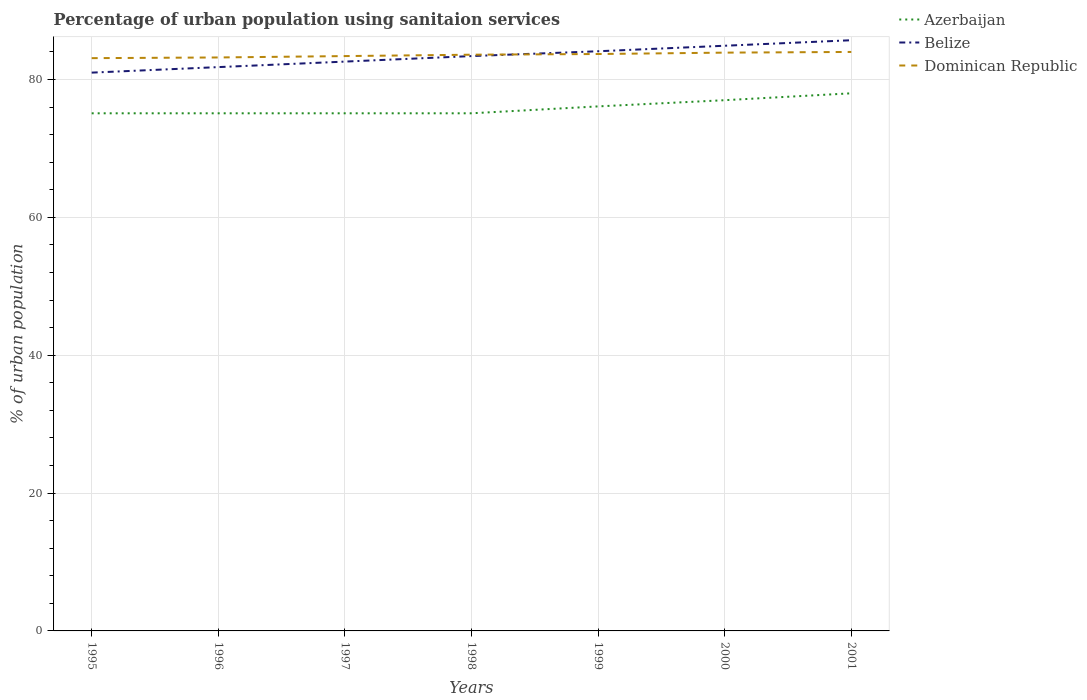Does the line corresponding to Belize intersect with the line corresponding to Dominican Republic?
Ensure brevity in your answer.  Yes. Is the number of lines equal to the number of legend labels?
Your answer should be compact. Yes. Across all years, what is the maximum percentage of urban population using sanitaion services in Dominican Republic?
Provide a short and direct response. 83.1. What is the total percentage of urban population using sanitaion services in Belize in the graph?
Provide a succinct answer. -0.8. What is the difference between the highest and the second highest percentage of urban population using sanitaion services in Belize?
Offer a terse response. 4.7. What is the difference between the highest and the lowest percentage of urban population using sanitaion services in Belize?
Provide a succinct answer. 4. How many years are there in the graph?
Make the answer very short. 7. Are the values on the major ticks of Y-axis written in scientific E-notation?
Your answer should be very brief. No. Does the graph contain any zero values?
Make the answer very short. No. How are the legend labels stacked?
Make the answer very short. Vertical. What is the title of the graph?
Your answer should be compact. Percentage of urban population using sanitaion services. Does "Benin" appear as one of the legend labels in the graph?
Your response must be concise. No. What is the label or title of the X-axis?
Offer a very short reply. Years. What is the label or title of the Y-axis?
Give a very brief answer. % of urban population. What is the % of urban population of Azerbaijan in 1995?
Your answer should be very brief. 75.1. What is the % of urban population in Dominican Republic in 1995?
Provide a succinct answer. 83.1. What is the % of urban population in Azerbaijan in 1996?
Your answer should be very brief. 75.1. What is the % of urban population of Belize in 1996?
Give a very brief answer. 81.8. What is the % of urban population of Dominican Republic in 1996?
Your answer should be very brief. 83.2. What is the % of urban population of Azerbaijan in 1997?
Make the answer very short. 75.1. What is the % of urban population of Belize in 1997?
Your answer should be compact. 82.6. What is the % of urban population of Dominican Republic in 1997?
Offer a terse response. 83.4. What is the % of urban population of Azerbaijan in 1998?
Make the answer very short. 75.1. What is the % of urban population of Belize in 1998?
Keep it short and to the point. 83.4. What is the % of urban population of Dominican Republic in 1998?
Your answer should be compact. 83.6. What is the % of urban population of Azerbaijan in 1999?
Offer a terse response. 76.1. What is the % of urban population of Belize in 1999?
Provide a succinct answer. 84.1. What is the % of urban population of Dominican Republic in 1999?
Provide a short and direct response. 83.7. What is the % of urban population of Belize in 2000?
Ensure brevity in your answer.  84.9. What is the % of urban population of Dominican Republic in 2000?
Your answer should be compact. 83.9. What is the % of urban population in Azerbaijan in 2001?
Your response must be concise. 78. What is the % of urban population in Belize in 2001?
Ensure brevity in your answer.  85.7. Across all years, what is the maximum % of urban population of Belize?
Your response must be concise. 85.7. Across all years, what is the maximum % of urban population of Dominican Republic?
Make the answer very short. 84. Across all years, what is the minimum % of urban population of Azerbaijan?
Give a very brief answer. 75.1. Across all years, what is the minimum % of urban population in Belize?
Keep it short and to the point. 81. Across all years, what is the minimum % of urban population in Dominican Republic?
Offer a very short reply. 83.1. What is the total % of urban population of Azerbaijan in the graph?
Provide a succinct answer. 531.5. What is the total % of urban population in Belize in the graph?
Ensure brevity in your answer.  583.5. What is the total % of urban population in Dominican Republic in the graph?
Your answer should be very brief. 584.9. What is the difference between the % of urban population in Belize in 1995 and that in 1996?
Your response must be concise. -0.8. What is the difference between the % of urban population of Belize in 1995 and that in 1997?
Offer a terse response. -1.6. What is the difference between the % of urban population of Dominican Republic in 1995 and that in 1997?
Keep it short and to the point. -0.3. What is the difference between the % of urban population in Azerbaijan in 1995 and that in 1998?
Offer a very short reply. 0. What is the difference between the % of urban population in Dominican Republic in 1995 and that in 1998?
Provide a short and direct response. -0.5. What is the difference between the % of urban population of Azerbaijan in 1995 and that in 1999?
Your response must be concise. -1. What is the difference between the % of urban population of Azerbaijan in 1995 and that in 2000?
Your answer should be compact. -1.9. What is the difference between the % of urban population in Dominican Republic in 1995 and that in 2000?
Your answer should be very brief. -0.8. What is the difference between the % of urban population in Dominican Republic in 1995 and that in 2001?
Keep it short and to the point. -0.9. What is the difference between the % of urban population of Belize in 1996 and that in 1997?
Offer a very short reply. -0.8. What is the difference between the % of urban population in Dominican Republic in 1996 and that in 1997?
Offer a very short reply. -0.2. What is the difference between the % of urban population of Azerbaijan in 1996 and that in 1998?
Keep it short and to the point. 0. What is the difference between the % of urban population of Belize in 1996 and that in 1998?
Provide a short and direct response. -1.6. What is the difference between the % of urban population in Dominican Republic in 1996 and that in 1998?
Ensure brevity in your answer.  -0.4. What is the difference between the % of urban population in Azerbaijan in 1996 and that in 1999?
Your answer should be compact. -1. What is the difference between the % of urban population of Dominican Republic in 1996 and that in 1999?
Provide a succinct answer. -0.5. What is the difference between the % of urban population in Azerbaijan in 1996 and that in 2000?
Make the answer very short. -1.9. What is the difference between the % of urban population in Belize in 1996 and that in 2000?
Make the answer very short. -3.1. What is the difference between the % of urban population in Dominican Republic in 1996 and that in 2000?
Offer a very short reply. -0.7. What is the difference between the % of urban population of Belize in 1996 and that in 2001?
Keep it short and to the point. -3.9. What is the difference between the % of urban population of Dominican Republic in 1996 and that in 2001?
Your response must be concise. -0.8. What is the difference between the % of urban population in Belize in 1997 and that in 1998?
Keep it short and to the point. -0.8. What is the difference between the % of urban population of Azerbaijan in 1997 and that in 1999?
Your response must be concise. -1. What is the difference between the % of urban population of Belize in 1997 and that in 1999?
Keep it short and to the point. -1.5. What is the difference between the % of urban population in Dominican Republic in 1997 and that in 1999?
Make the answer very short. -0.3. What is the difference between the % of urban population of Azerbaijan in 1997 and that in 2001?
Your answer should be very brief. -2.9. What is the difference between the % of urban population in Belize in 1997 and that in 2001?
Give a very brief answer. -3.1. What is the difference between the % of urban population of Azerbaijan in 1998 and that in 1999?
Your answer should be compact. -1. What is the difference between the % of urban population in Dominican Republic in 1998 and that in 1999?
Provide a short and direct response. -0.1. What is the difference between the % of urban population of Azerbaijan in 1998 and that in 2000?
Offer a terse response. -1.9. What is the difference between the % of urban population in Dominican Republic in 1998 and that in 2000?
Your response must be concise. -0.3. What is the difference between the % of urban population of Azerbaijan in 1998 and that in 2001?
Your response must be concise. -2.9. What is the difference between the % of urban population in Belize in 1998 and that in 2001?
Provide a short and direct response. -2.3. What is the difference between the % of urban population of Dominican Republic in 1998 and that in 2001?
Your response must be concise. -0.4. What is the difference between the % of urban population of Belize in 1999 and that in 2000?
Offer a terse response. -0.8. What is the difference between the % of urban population in Azerbaijan in 1999 and that in 2001?
Make the answer very short. -1.9. What is the difference between the % of urban population of Belize in 1999 and that in 2001?
Keep it short and to the point. -1.6. What is the difference between the % of urban population of Azerbaijan in 2000 and that in 2001?
Keep it short and to the point. -1. What is the difference between the % of urban population of Dominican Republic in 2000 and that in 2001?
Your answer should be compact. -0.1. What is the difference between the % of urban population in Azerbaijan in 1995 and the % of urban population in Belize in 1996?
Ensure brevity in your answer.  -6.7. What is the difference between the % of urban population in Azerbaijan in 1995 and the % of urban population in Dominican Republic in 1996?
Ensure brevity in your answer.  -8.1. What is the difference between the % of urban population in Azerbaijan in 1995 and the % of urban population in Dominican Republic in 1997?
Offer a very short reply. -8.3. What is the difference between the % of urban population of Azerbaijan in 1995 and the % of urban population of Belize in 1998?
Offer a terse response. -8.3. What is the difference between the % of urban population in Azerbaijan in 1995 and the % of urban population in Dominican Republic in 1998?
Make the answer very short. -8.5. What is the difference between the % of urban population of Belize in 1995 and the % of urban population of Dominican Republic in 1998?
Your response must be concise. -2.6. What is the difference between the % of urban population of Azerbaijan in 1995 and the % of urban population of Dominican Republic in 1999?
Give a very brief answer. -8.6. What is the difference between the % of urban population in Belize in 1995 and the % of urban population in Dominican Republic in 1999?
Your answer should be very brief. -2.7. What is the difference between the % of urban population in Azerbaijan in 1995 and the % of urban population in Belize in 2001?
Offer a terse response. -10.6. What is the difference between the % of urban population of Belize in 1995 and the % of urban population of Dominican Republic in 2001?
Provide a succinct answer. -3. What is the difference between the % of urban population of Azerbaijan in 1996 and the % of urban population of Dominican Republic in 1997?
Make the answer very short. -8.3. What is the difference between the % of urban population in Belize in 1996 and the % of urban population in Dominican Republic in 1997?
Provide a short and direct response. -1.6. What is the difference between the % of urban population in Azerbaijan in 1996 and the % of urban population in Dominican Republic in 1999?
Give a very brief answer. -8.6. What is the difference between the % of urban population of Azerbaijan in 1996 and the % of urban population of Dominican Republic in 2000?
Make the answer very short. -8.8. What is the difference between the % of urban population of Belize in 1996 and the % of urban population of Dominican Republic in 2000?
Keep it short and to the point. -2.1. What is the difference between the % of urban population of Azerbaijan in 1996 and the % of urban population of Belize in 2001?
Provide a succinct answer. -10.6. What is the difference between the % of urban population in Azerbaijan in 1997 and the % of urban population in Belize in 1998?
Make the answer very short. -8.3. What is the difference between the % of urban population of Belize in 1997 and the % of urban population of Dominican Republic in 1999?
Offer a very short reply. -1.1. What is the difference between the % of urban population in Azerbaijan in 1997 and the % of urban population in Belize in 2000?
Ensure brevity in your answer.  -9.8. What is the difference between the % of urban population in Belize in 1997 and the % of urban population in Dominican Republic in 2000?
Make the answer very short. -1.3. What is the difference between the % of urban population in Azerbaijan in 1997 and the % of urban population in Belize in 2001?
Provide a short and direct response. -10.6. What is the difference between the % of urban population in Azerbaijan in 1997 and the % of urban population in Dominican Republic in 2001?
Provide a short and direct response. -8.9. What is the difference between the % of urban population of Belize in 1997 and the % of urban population of Dominican Republic in 2001?
Give a very brief answer. -1.4. What is the difference between the % of urban population of Azerbaijan in 1998 and the % of urban population of Belize in 1999?
Keep it short and to the point. -9. What is the difference between the % of urban population in Belize in 1998 and the % of urban population in Dominican Republic in 1999?
Offer a terse response. -0.3. What is the difference between the % of urban population in Azerbaijan in 1998 and the % of urban population in Belize in 2000?
Give a very brief answer. -9.8. What is the difference between the % of urban population of Azerbaijan in 1998 and the % of urban population of Dominican Republic in 2000?
Provide a short and direct response. -8.8. What is the difference between the % of urban population of Belize in 1998 and the % of urban population of Dominican Republic in 2000?
Your response must be concise. -0.5. What is the difference between the % of urban population in Azerbaijan in 1998 and the % of urban population in Dominican Republic in 2001?
Make the answer very short. -8.9. What is the difference between the % of urban population in Azerbaijan in 1999 and the % of urban population in Belize in 2000?
Offer a terse response. -8.8. What is the difference between the % of urban population in Azerbaijan in 1999 and the % of urban population in Dominican Republic in 2000?
Ensure brevity in your answer.  -7.8. What is the difference between the % of urban population of Belize in 1999 and the % of urban population of Dominican Republic in 2001?
Make the answer very short. 0.1. What is the difference between the % of urban population of Azerbaijan in 2000 and the % of urban population of Belize in 2001?
Make the answer very short. -8.7. What is the difference between the % of urban population of Azerbaijan in 2000 and the % of urban population of Dominican Republic in 2001?
Offer a terse response. -7. What is the average % of urban population of Azerbaijan per year?
Give a very brief answer. 75.93. What is the average % of urban population of Belize per year?
Keep it short and to the point. 83.36. What is the average % of urban population in Dominican Republic per year?
Your answer should be compact. 83.56. In the year 1995, what is the difference between the % of urban population in Azerbaijan and % of urban population in Belize?
Your answer should be compact. -5.9. In the year 1995, what is the difference between the % of urban population of Azerbaijan and % of urban population of Dominican Republic?
Keep it short and to the point. -8. In the year 1995, what is the difference between the % of urban population in Belize and % of urban population in Dominican Republic?
Keep it short and to the point. -2.1. In the year 1996, what is the difference between the % of urban population in Azerbaijan and % of urban population in Belize?
Provide a short and direct response. -6.7. In the year 1996, what is the difference between the % of urban population of Azerbaijan and % of urban population of Dominican Republic?
Provide a succinct answer. -8.1. In the year 1997, what is the difference between the % of urban population of Azerbaijan and % of urban population of Belize?
Keep it short and to the point. -7.5. In the year 1997, what is the difference between the % of urban population of Belize and % of urban population of Dominican Republic?
Provide a succinct answer. -0.8. In the year 1999, what is the difference between the % of urban population of Azerbaijan and % of urban population of Dominican Republic?
Make the answer very short. -7.6. In the year 2000, what is the difference between the % of urban population of Azerbaijan and % of urban population of Dominican Republic?
Make the answer very short. -6.9. What is the ratio of the % of urban population in Azerbaijan in 1995 to that in 1996?
Offer a very short reply. 1. What is the ratio of the % of urban population in Belize in 1995 to that in 1996?
Offer a terse response. 0.99. What is the ratio of the % of urban population in Azerbaijan in 1995 to that in 1997?
Ensure brevity in your answer.  1. What is the ratio of the % of urban population of Belize in 1995 to that in 1997?
Ensure brevity in your answer.  0.98. What is the ratio of the % of urban population of Dominican Republic in 1995 to that in 1997?
Give a very brief answer. 1. What is the ratio of the % of urban population in Azerbaijan in 1995 to that in 1998?
Keep it short and to the point. 1. What is the ratio of the % of urban population in Belize in 1995 to that in 1998?
Give a very brief answer. 0.97. What is the ratio of the % of urban population of Azerbaijan in 1995 to that in 1999?
Your answer should be very brief. 0.99. What is the ratio of the % of urban population of Belize in 1995 to that in 1999?
Give a very brief answer. 0.96. What is the ratio of the % of urban population in Dominican Republic in 1995 to that in 1999?
Offer a terse response. 0.99. What is the ratio of the % of urban population of Azerbaijan in 1995 to that in 2000?
Provide a succinct answer. 0.98. What is the ratio of the % of urban population of Belize in 1995 to that in 2000?
Offer a very short reply. 0.95. What is the ratio of the % of urban population of Dominican Republic in 1995 to that in 2000?
Ensure brevity in your answer.  0.99. What is the ratio of the % of urban population in Azerbaijan in 1995 to that in 2001?
Provide a succinct answer. 0.96. What is the ratio of the % of urban population in Belize in 1995 to that in 2001?
Offer a terse response. 0.95. What is the ratio of the % of urban population in Dominican Republic in 1995 to that in 2001?
Give a very brief answer. 0.99. What is the ratio of the % of urban population of Azerbaijan in 1996 to that in 1997?
Your answer should be compact. 1. What is the ratio of the % of urban population of Belize in 1996 to that in 1997?
Provide a succinct answer. 0.99. What is the ratio of the % of urban population in Dominican Republic in 1996 to that in 1997?
Ensure brevity in your answer.  1. What is the ratio of the % of urban population of Belize in 1996 to that in 1998?
Your answer should be very brief. 0.98. What is the ratio of the % of urban population in Dominican Republic in 1996 to that in 1998?
Offer a very short reply. 1. What is the ratio of the % of urban population of Azerbaijan in 1996 to that in 1999?
Your response must be concise. 0.99. What is the ratio of the % of urban population in Belize in 1996 to that in 1999?
Offer a very short reply. 0.97. What is the ratio of the % of urban population of Dominican Republic in 1996 to that in 1999?
Ensure brevity in your answer.  0.99. What is the ratio of the % of urban population of Azerbaijan in 1996 to that in 2000?
Provide a succinct answer. 0.98. What is the ratio of the % of urban population of Belize in 1996 to that in 2000?
Give a very brief answer. 0.96. What is the ratio of the % of urban population in Azerbaijan in 1996 to that in 2001?
Your answer should be very brief. 0.96. What is the ratio of the % of urban population of Belize in 1996 to that in 2001?
Provide a short and direct response. 0.95. What is the ratio of the % of urban population of Dominican Republic in 1996 to that in 2001?
Keep it short and to the point. 0.99. What is the ratio of the % of urban population of Dominican Republic in 1997 to that in 1998?
Provide a succinct answer. 1. What is the ratio of the % of urban population in Azerbaijan in 1997 to that in 1999?
Offer a terse response. 0.99. What is the ratio of the % of urban population of Belize in 1997 to that in 1999?
Make the answer very short. 0.98. What is the ratio of the % of urban population of Azerbaijan in 1997 to that in 2000?
Make the answer very short. 0.98. What is the ratio of the % of urban population of Belize in 1997 to that in 2000?
Your answer should be very brief. 0.97. What is the ratio of the % of urban population in Dominican Republic in 1997 to that in 2000?
Provide a short and direct response. 0.99. What is the ratio of the % of urban population of Azerbaijan in 1997 to that in 2001?
Your answer should be very brief. 0.96. What is the ratio of the % of urban population of Belize in 1997 to that in 2001?
Your response must be concise. 0.96. What is the ratio of the % of urban population in Azerbaijan in 1998 to that in 1999?
Offer a terse response. 0.99. What is the ratio of the % of urban population of Azerbaijan in 1998 to that in 2000?
Your answer should be very brief. 0.98. What is the ratio of the % of urban population in Belize in 1998 to that in 2000?
Keep it short and to the point. 0.98. What is the ratio of the % of urban population in Dominican Republic in 1998 to that in 2000?
Your answer should be compact. 1. What is the ratio of the % of urban population in Azerbaijan in 1998 to that in 2001?
Your answer should be very brief. 0.96. What is the ratio of the % of urban population in Belize in 1998 to that in 2001?
Offer a very short reply. 0.97. What is the ratio of the % of urban population in Dominican Republic in 1998 to that in 2001?
Provide a short and direct response. 1. What is the ratio of the % of urban population in Azerbaijan in 1999 to that in 2000?
Keep it short and to the point. 0.99. What is the ratio of the % of urban population in Belize in 1999 to that in 2000?
Make the answer very short. 0.99. What is the ratio of the % of urban population of Dominican Republic in 1999 to that in 2000?
Ensure brevity in your answer.  1. What is the ratio of the % of urban population in Azerbaijan in 1999 to that in 2001?
Provide a short and direct response. 0.98. What is the ratio of the % of urban population of Belize in 1999 to that in 2001?
Your answer should be compact. 0.98. What is the ratio of the % of urban population in Azerbaijan in 2000 to that in 2001?
Make the answer very short. 0.99. What is the ratio of the % of urban population in Dominican Republic in 2000 to that in 2001?
Make the answer very short. 1. What is the difference between the highest and the second highest % of urban population of Belize?
Your answer should be compact. 0.8. What is the difference between the highest and the second highest % of urban population of Dominican Republic?
Keep it short and to the point. 0.1. 